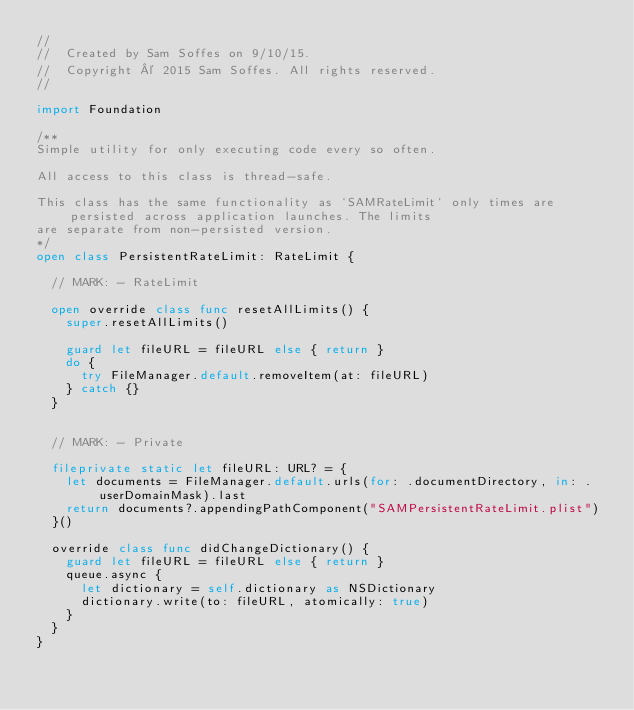<code> <loc_0><loc_0><loc_500><loc_500><_Swift_>//
//  Created by Sam Soffes on 9/10/15.
//  Copyright © 2015 Sam Soffes. All rights reserved.
//

import Foundation

/**
Simple utility for only executing code every so often.

All access to this class is thread-safe.

This class has the same functionality as `SAMRateLimit` only times are persisted across application launches. The limits
are separate from non-persisted version.
*/
open class PersistentRateLimit: RateLimit {

	// MARK: - RateLimit

	open override class func resetAllLimits() {
		super.resetAllLimits()

		guard let fileURL = fileURL else { return }
		do {
			try FileManager.default.removeItem(at: fileURL)
		} catch {}
	}


	// MARK: - Private

	fileprivate static let fileURL: URL? = {
		let documents = FileManager.default.urls(for: .documentDirectory, in: .userDomainMask).last
		return documents?.appendingPathComponent("SAMPersistentRateLimit.plist")
	}()

	override class func didChangeDictionary() {
		guard let fileURL = fileURL else { return }
		queue.async {
			let dictionary = self.dictionary as NSDictionary
			dictionary.write(to: fileURL, atomically: true)
		}
	}
}
</code> 